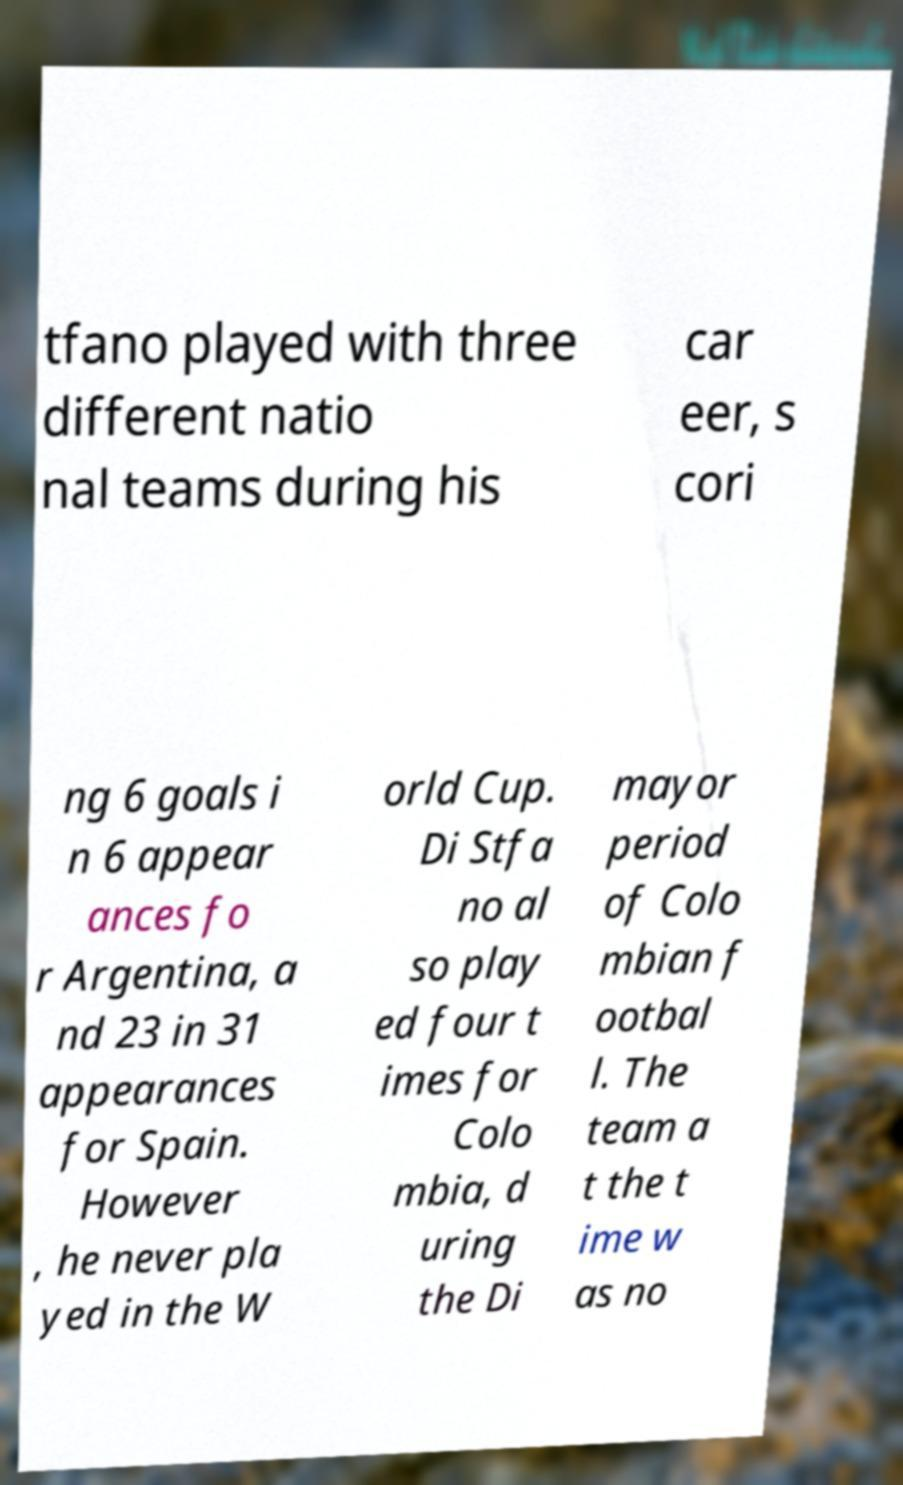Could you extract and type out the text from this image? tfano played with three different natio nal teams during his car eer, s cori ng 6 goals i n 6 appear ances fo r Argentina, a nd 23 in 31 appearances for Spain. However , he never pla yed in the W orld Cup. Di Stfa no al so play ed four t imes for Colo mbia, d uring the Di mayor period of Colo mbian f ootbal l. The team a t the t ime w as no 